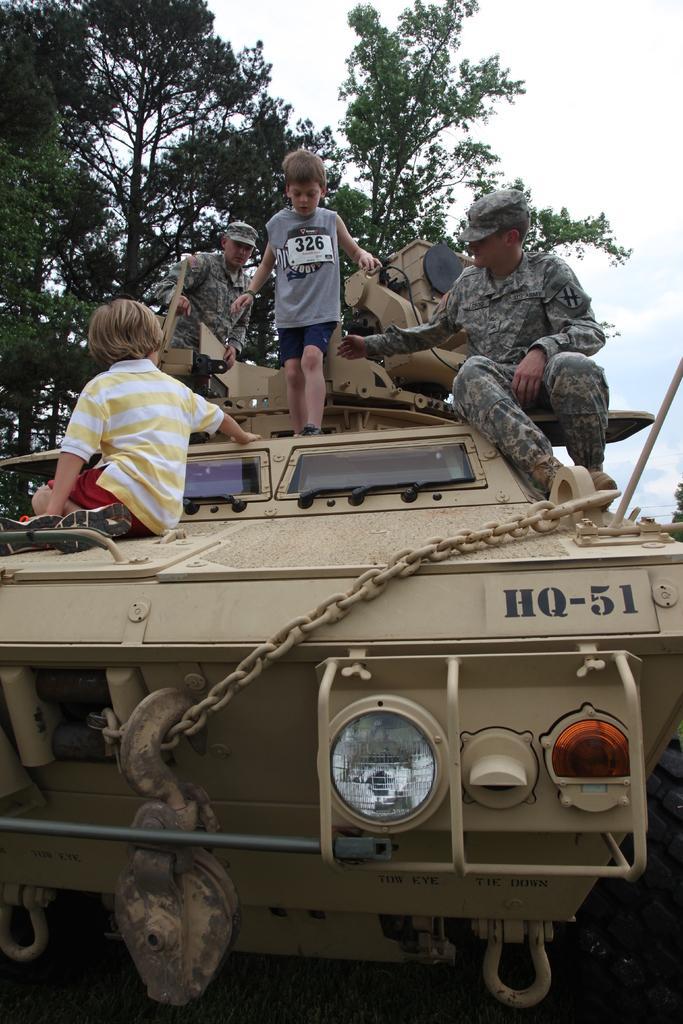Describe this image in one or two sentences. In this image we can see some people sitting on a vehicle. We can also see a child standing on that. On the backside we can see some trees and the sky which looks cloudy. 